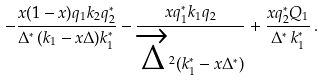<formula> <loc_0><loc_0><loc_500><loc_500>- \frac { x ( 1 - x ) q _ { 1 } k _ { 2 } q _ { 2 } ^ { * } } { \Delta ^ { * } \, ( k _ { 1 } - x \Delta ) k _ { 1 } ^ { * } } - \frac { x q _ { 1 } ^ { * } k _ { 1 } q _ { 2 } } { \overrightarrow { \Delta } ^ { 2 } ( k _ { 1 } ^ { * } - x \Delta ^ { * } ) } + \frac { x q _ { 2 } ^ { * } Q _ { 1 } } { \Delta ^ { * } \, k _ { 1 } ^ { * } } \, .</formula> 